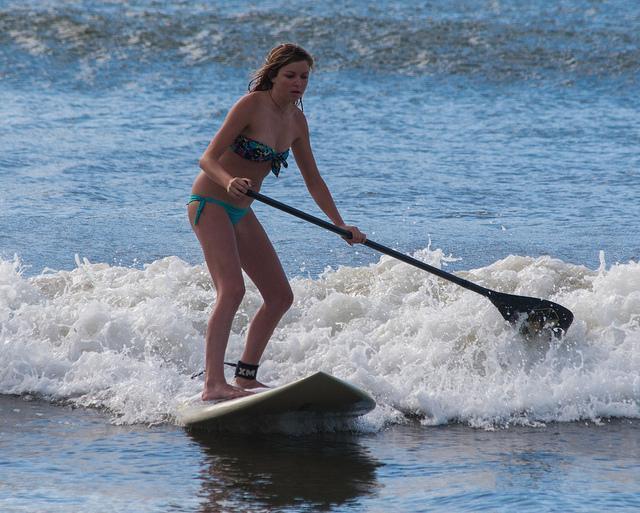How many people are visible?
Give a very brief answer. 1. 